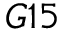<formula> <loc_0><loc_0><loc_500><loc_500>G 1 5</formula> 